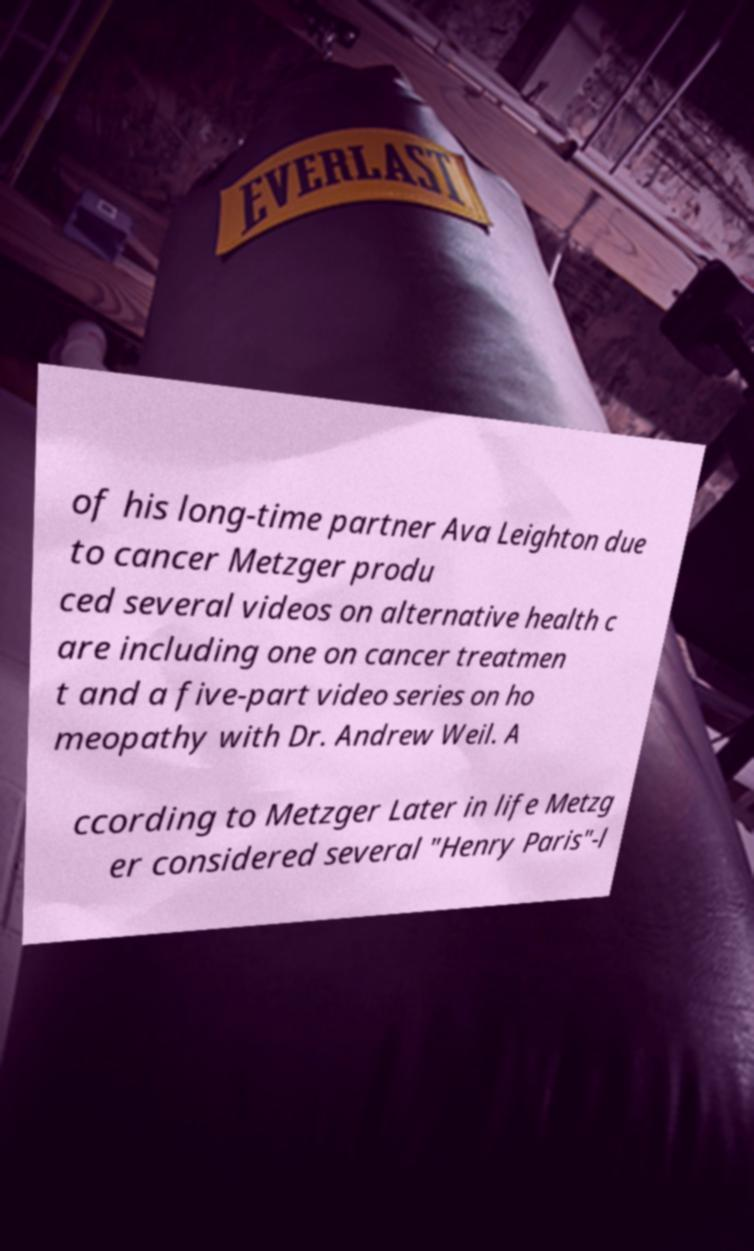Please read and relay the text visible in this image. What does it say? of his long-time partner Ava Leighton due to cancer Metzger produ ced several videos on alternative health c are including one on cancer treatmen t and a five-part video series on ho meopathy with Dr. Andrew Weil. A ccording to Metzger Later in life Metzg er considered several "Henry Paris"-l 